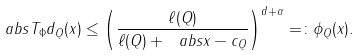<formula> <loc_0><loc_0><loc_500><loc_500>\ a b s { T _ { \Phi } d _ { Q } ( x ) } \leq \left ( \frac { \ell ( Q ) } { \ell ( Q ) + \ a b s { x - c _ { Q } } } \right ) ^ { d + \alpha } = \colon \phi _ { Q } ( x ) .</formula> 